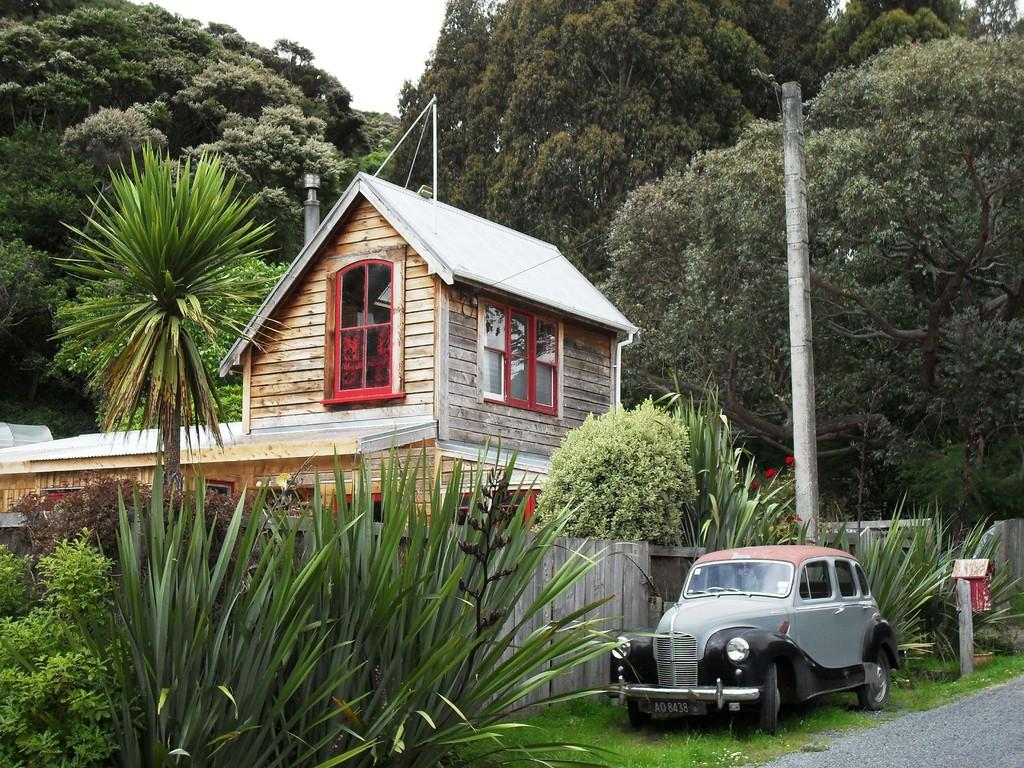What is the main feature in the center of the image? There is a sky in the center of the image. What type of natural elements can be seen in the image? There are trees, plants, and grass in the image. What type of structure is present in the image? There is a house in the image, which has windows. What else can be seen in the image besides the sky, trees, and house? There is a vehicle, a road, and poles in the image. How many eggs are visible in the image? There are no eggs present in the image. What type of toothbrush is being used by the house in the image? There is no toothbrush present in the image, and houses do not use toothbrushes. 